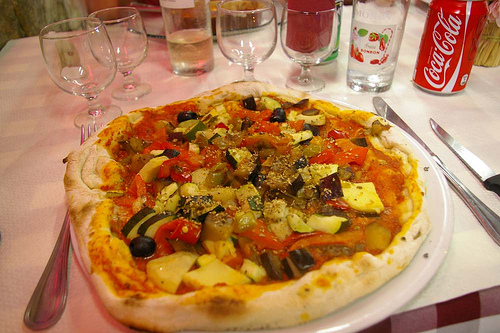Describe the setting in which the pizza is placed. What items accompany it on the table? The pizza is placed in a cozy dining setting, accompanied by several clear and colored glasses, presumably for drinks, an empty bottle suggesting a meal just enjoyed, and a Coca Cola can, adding a familiar touch to the feast. 